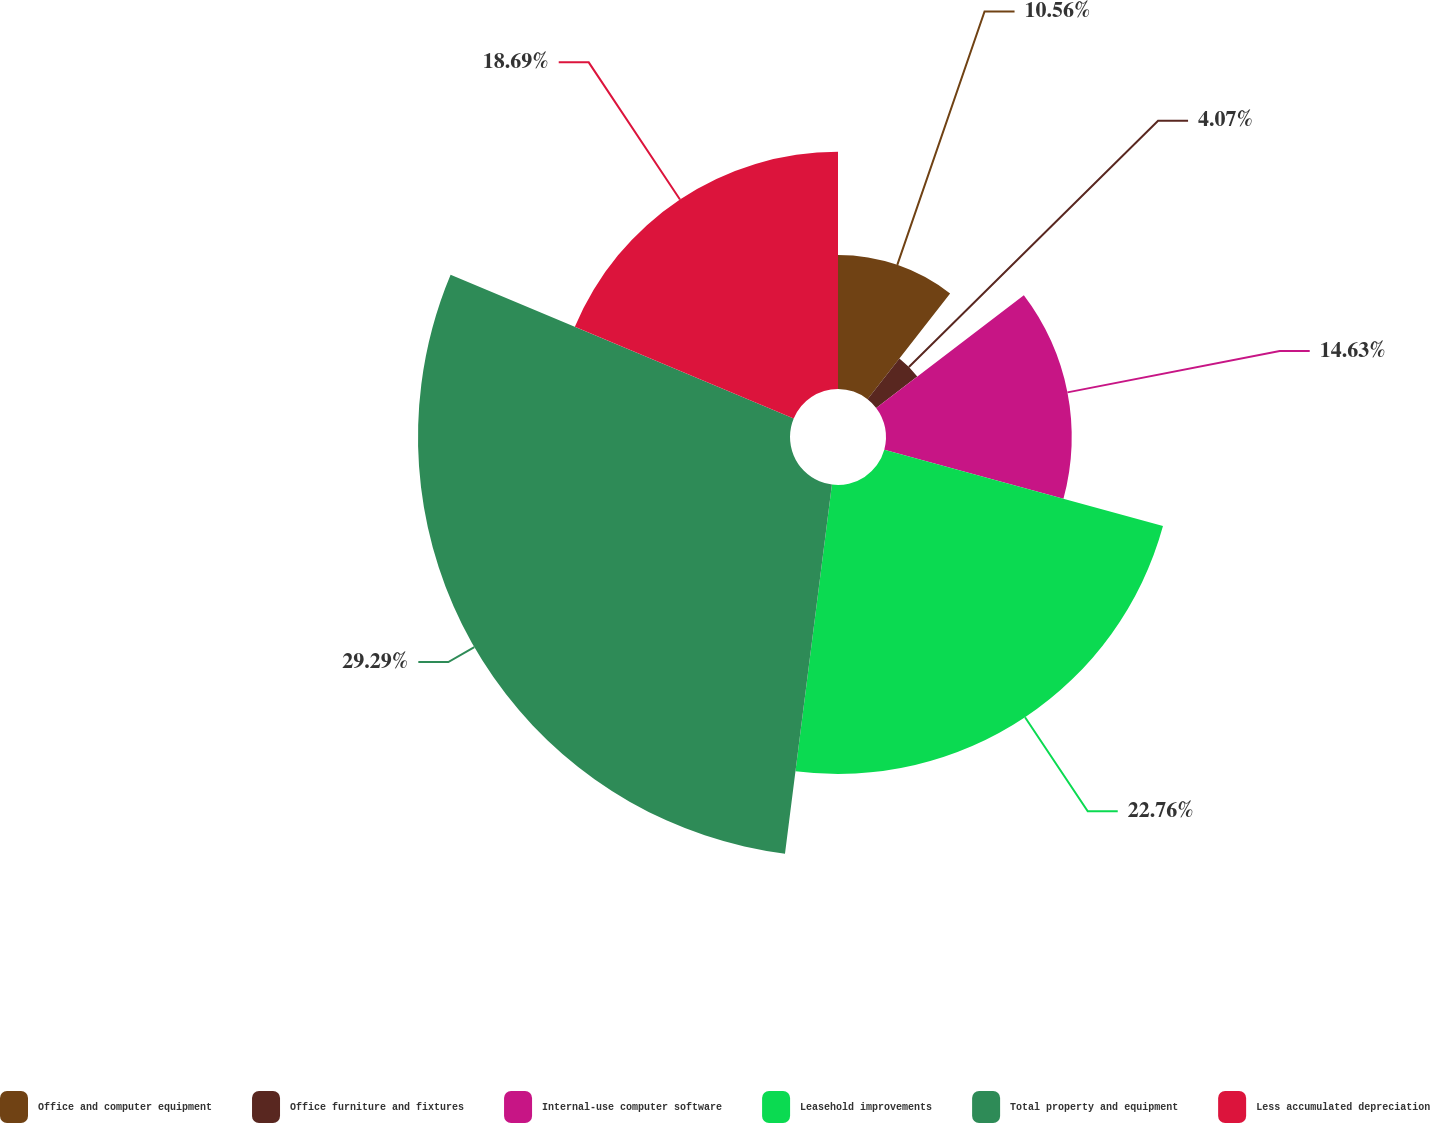Convert chart to OTSL. <chart><loc_0><loc_0><loc_500><loc_500><pie_chart><fcel>Office and computer equipment<fcel>Office furniture and fixtures<fcel>Internal-use computer software<fcel>Leasehold improvements<fcel>Total property and equipment<fcel>Less accumulated depreciation<nl><fcel>10.56%<fcel>4.07%<fcel>14.63%<fcel>22.76%<fcel>29.3%<fcel>18.69%<nl></chart> 